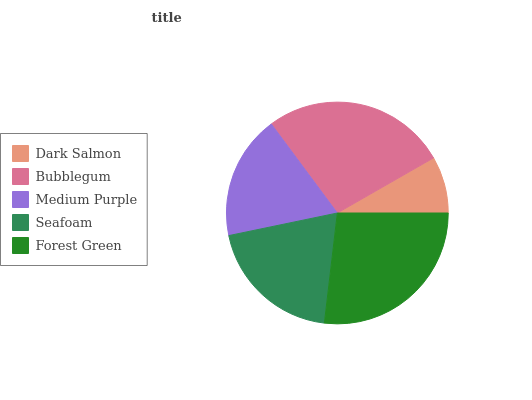Is Dark Salmon the minimum?
Answer yes or no. Yes. Is Bubblegum the maximum?
Answer yes or no. Yes. Is Medium Purple the minimum?
Answer yes or no. No. Is Medium Purple the maximum?
Answer yes or no. No. Is Bubblegum greater than Medium Purple?
Answer yes or no. Yes. Is Medium Purple less than Bubblegum?
Answer yes or no. Yes. Is Medium Purple greater than Bubblegum?
Answer yes or no. No. Is Bubblegum less than Medium Purple?
Answer yes or no. No. Is Seafoam the high median?
Answer yes or no. Yes. Is Seafoam the low median?
Answer yes or no. Yes. Is Medium Purple the high median?
Answer yes or no. No. Is Medium Purple the low median?
Answer yes or no. No. 